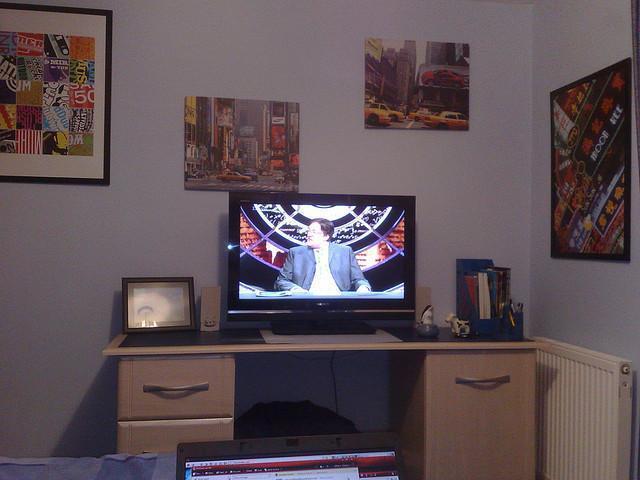What kind of artwork is framed on the left side of the screen on the wall?
Answer the question by selecting the correct answer among the 4 following choices.
Options: Abstract, contemporary, impressionism, american pop. American pop. 